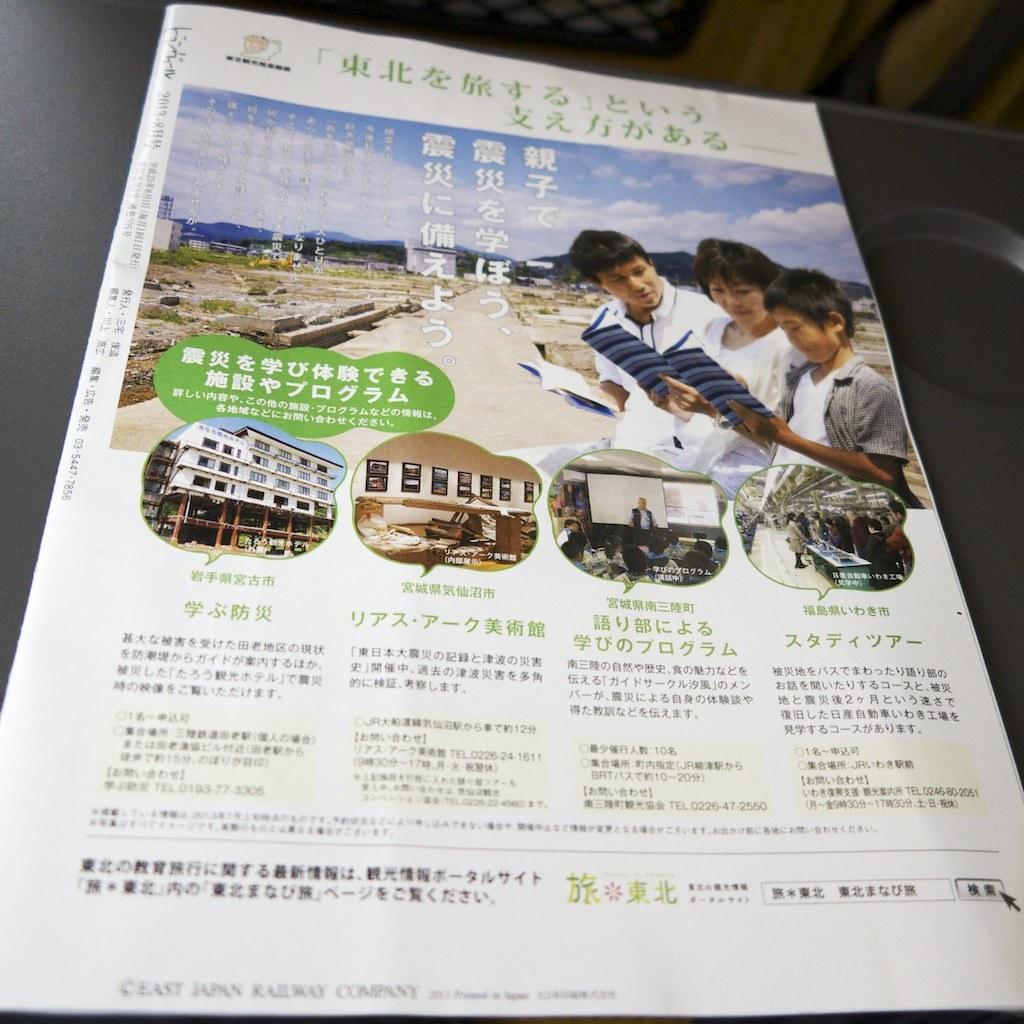Please provide a concise description of this image. In this picture, it seems like a poster, where we can see, people, buildings and text on it. 